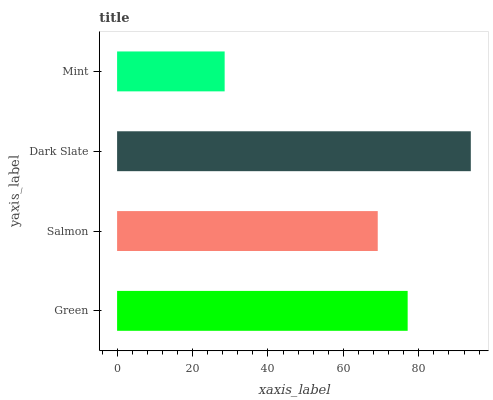Is Mint the minimum?
Answer yes or no. Yes. Is Dark Slate the maximum?
Answer yes or no. Yes. Is Salmon the minimum?
Answer yes or no. No. Is Salmon the maximum?
Answer yes or no. No. Is Green greater than Salmon?
Answer yes or no. Yes. Is Salmon less than Green?
Answer yes or no. Yes. Is Salmon greater than Green?
Answer yes or no. No. Is Green less than Salmon?
Answer yes or no. No. Is Green the high median?
Answer yes or no. Yes. Is Salmon the low median?
Answer yes or no. Yes. Is Dark Slate the high median?
Answer yes or no. No. Is Dark Slate the low median?
Answer yes or no. No. 